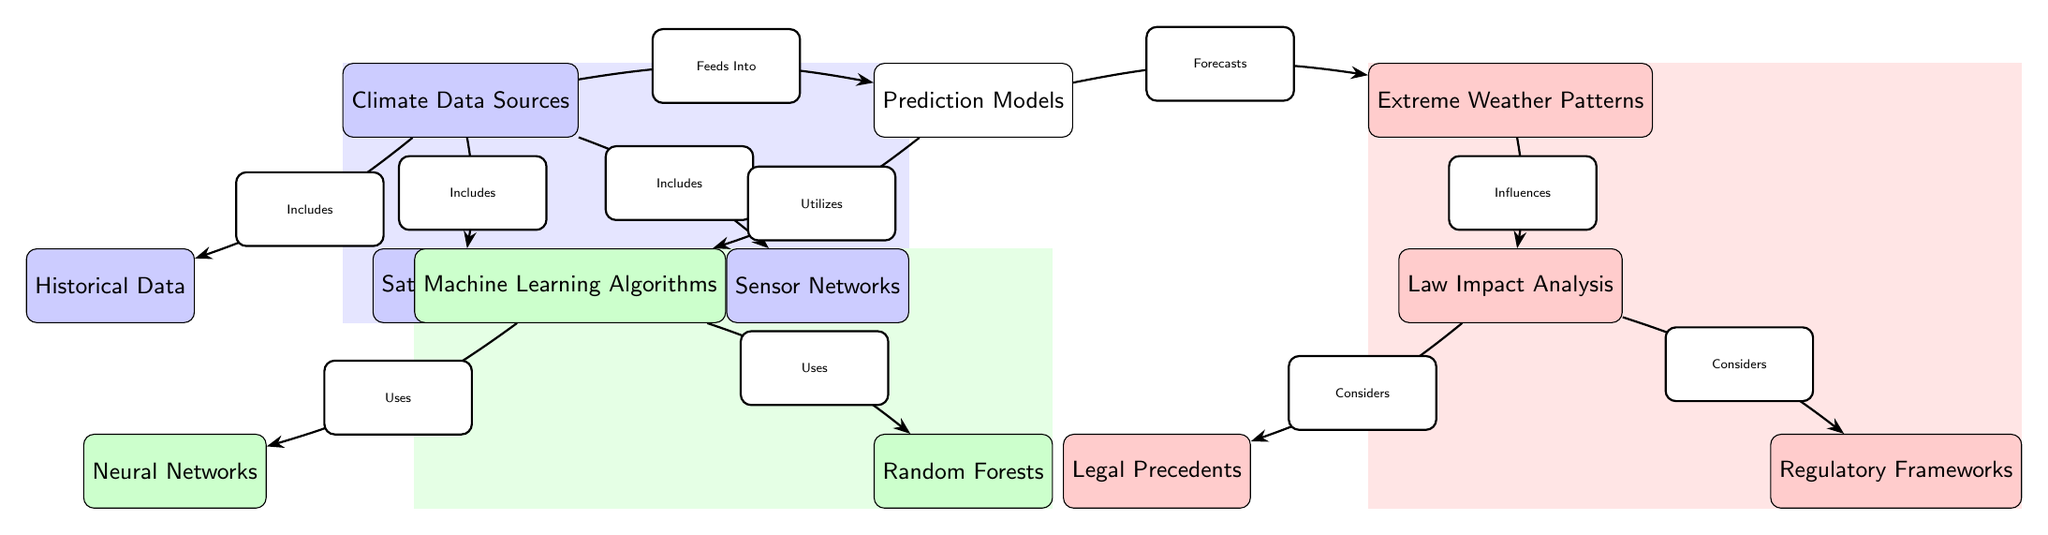What are the three sources of climate data mentioned? The diagram specifically lists three sources of climate data: Historical Data, Satellite Images, and Sensor Networks. These are found directly beneath the "Climate Data Sources" node.
Answer: Historical Data, Satellite Images, Sensor Networks How many machine learning algorithms are utilized in the prediction models? There are two machine learning algorithms listed under the "Machine Learning Algorithms" node: Neural Networks and Random Forests. This information can be directly observed in the diagram.
Answer: 2 Which node is influenced by extreme weather patterns? The "Law Impact Analysis" node is directly influenced by the "Extreme Weather Patterns" node as indicated by the arrow connecting them in the diagram.
Answer: Law Impact Analysis What is the relationship between climate data sources and prediction models? The "Climate Data Sources" node feeds into the "Prediction Models" node, as indicated by the arrow showing the flow of information from one node to the other in the diagram.
Answer: Feeds Into Which legal framework is considered in the law impact analysis? The diagram indicates that "Regulatory Frameworks" are considered in the "Law Impact Analysis." This is shown by the arrow pointing from "Law Impact Analysis" to "Regulatory Frameworks."
Answer: Regulatory Frameworks What type of algorithms are mentioned under machine learning algorithms? The diagram specifies that Neural Networks and Random Forests are the types of algorithms used under "Machine Learning Algorithms." This is shown in the sub-nodes branching from Machine Learning Algorithms.
Answer: Neural Networks, Random Forests How does machine learning contribute to forecasting extreme weather patterns? Machine Learning Algorithms are utilized by Prediction Models to forecast Extreme Weather Patterns, as illustrated by the flow from one node to the next in the diagram.
Answer: Utilizes What do legal precedents consider in their analysis? The "Law Impact Analysis" considers "Legal Precedents" as indicated by the arrow showing a direct relationship from one node to the other.
Answer: Legal Precedents 